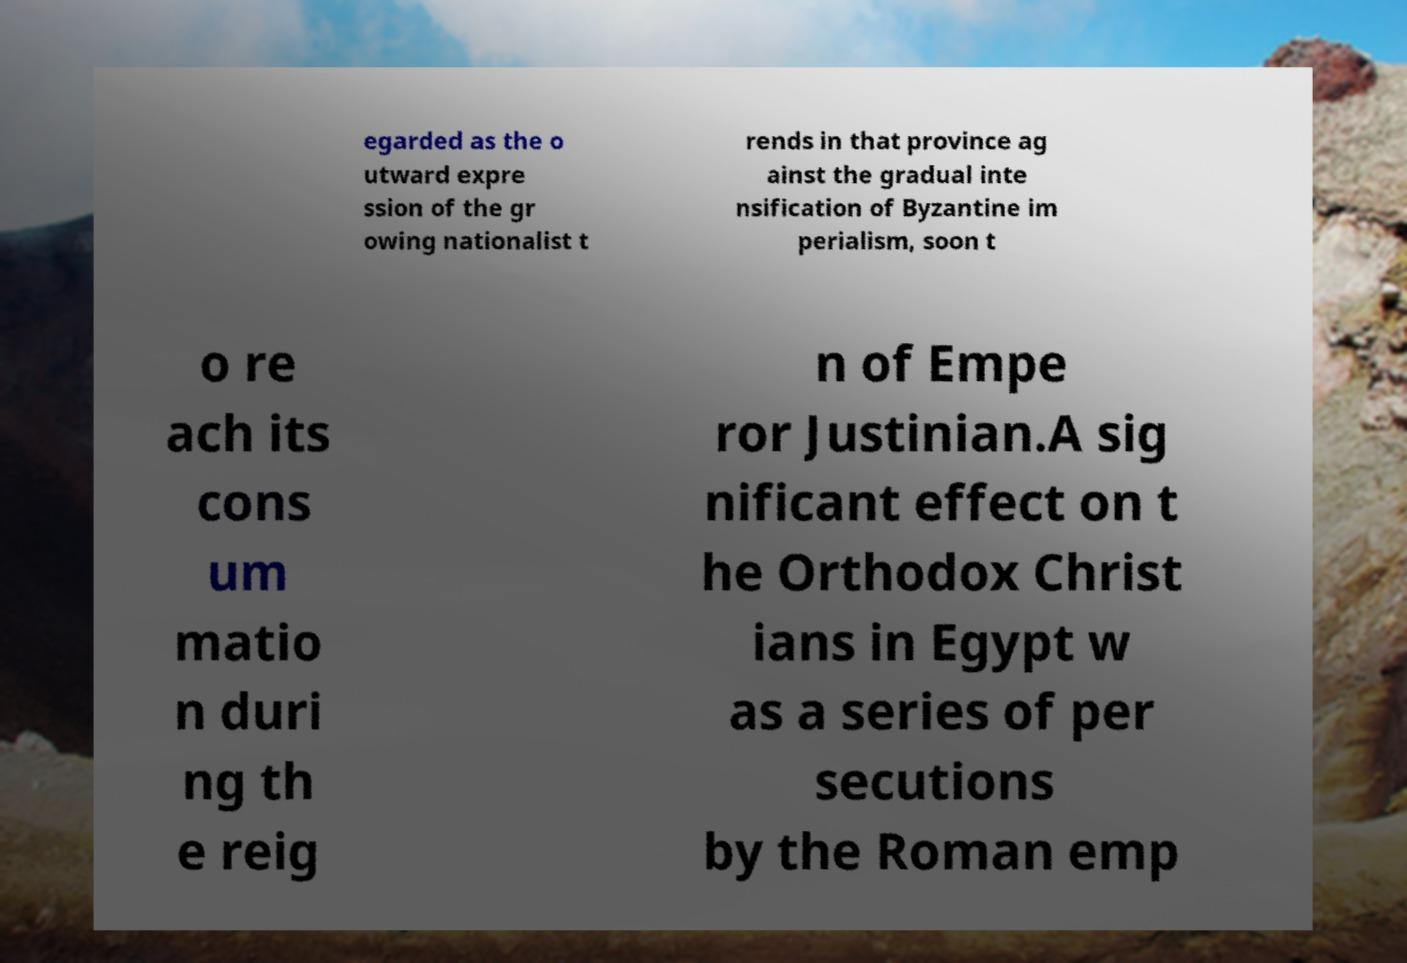For documentation purposes, I need the text within this image transcribed. Could you provide that? egarded as the o utward expre ssion of the gr owing nationalist t rends in that province ag ainst the gradual inte nsification of Byzantine im perialism, soon t o re ach its cons um matio n duri ng th e reig n of Empe ror Justinian.A sig nificant effect on t he Orthodox Christ ians in Egypt w as a series of per secutions by the Roman emp 